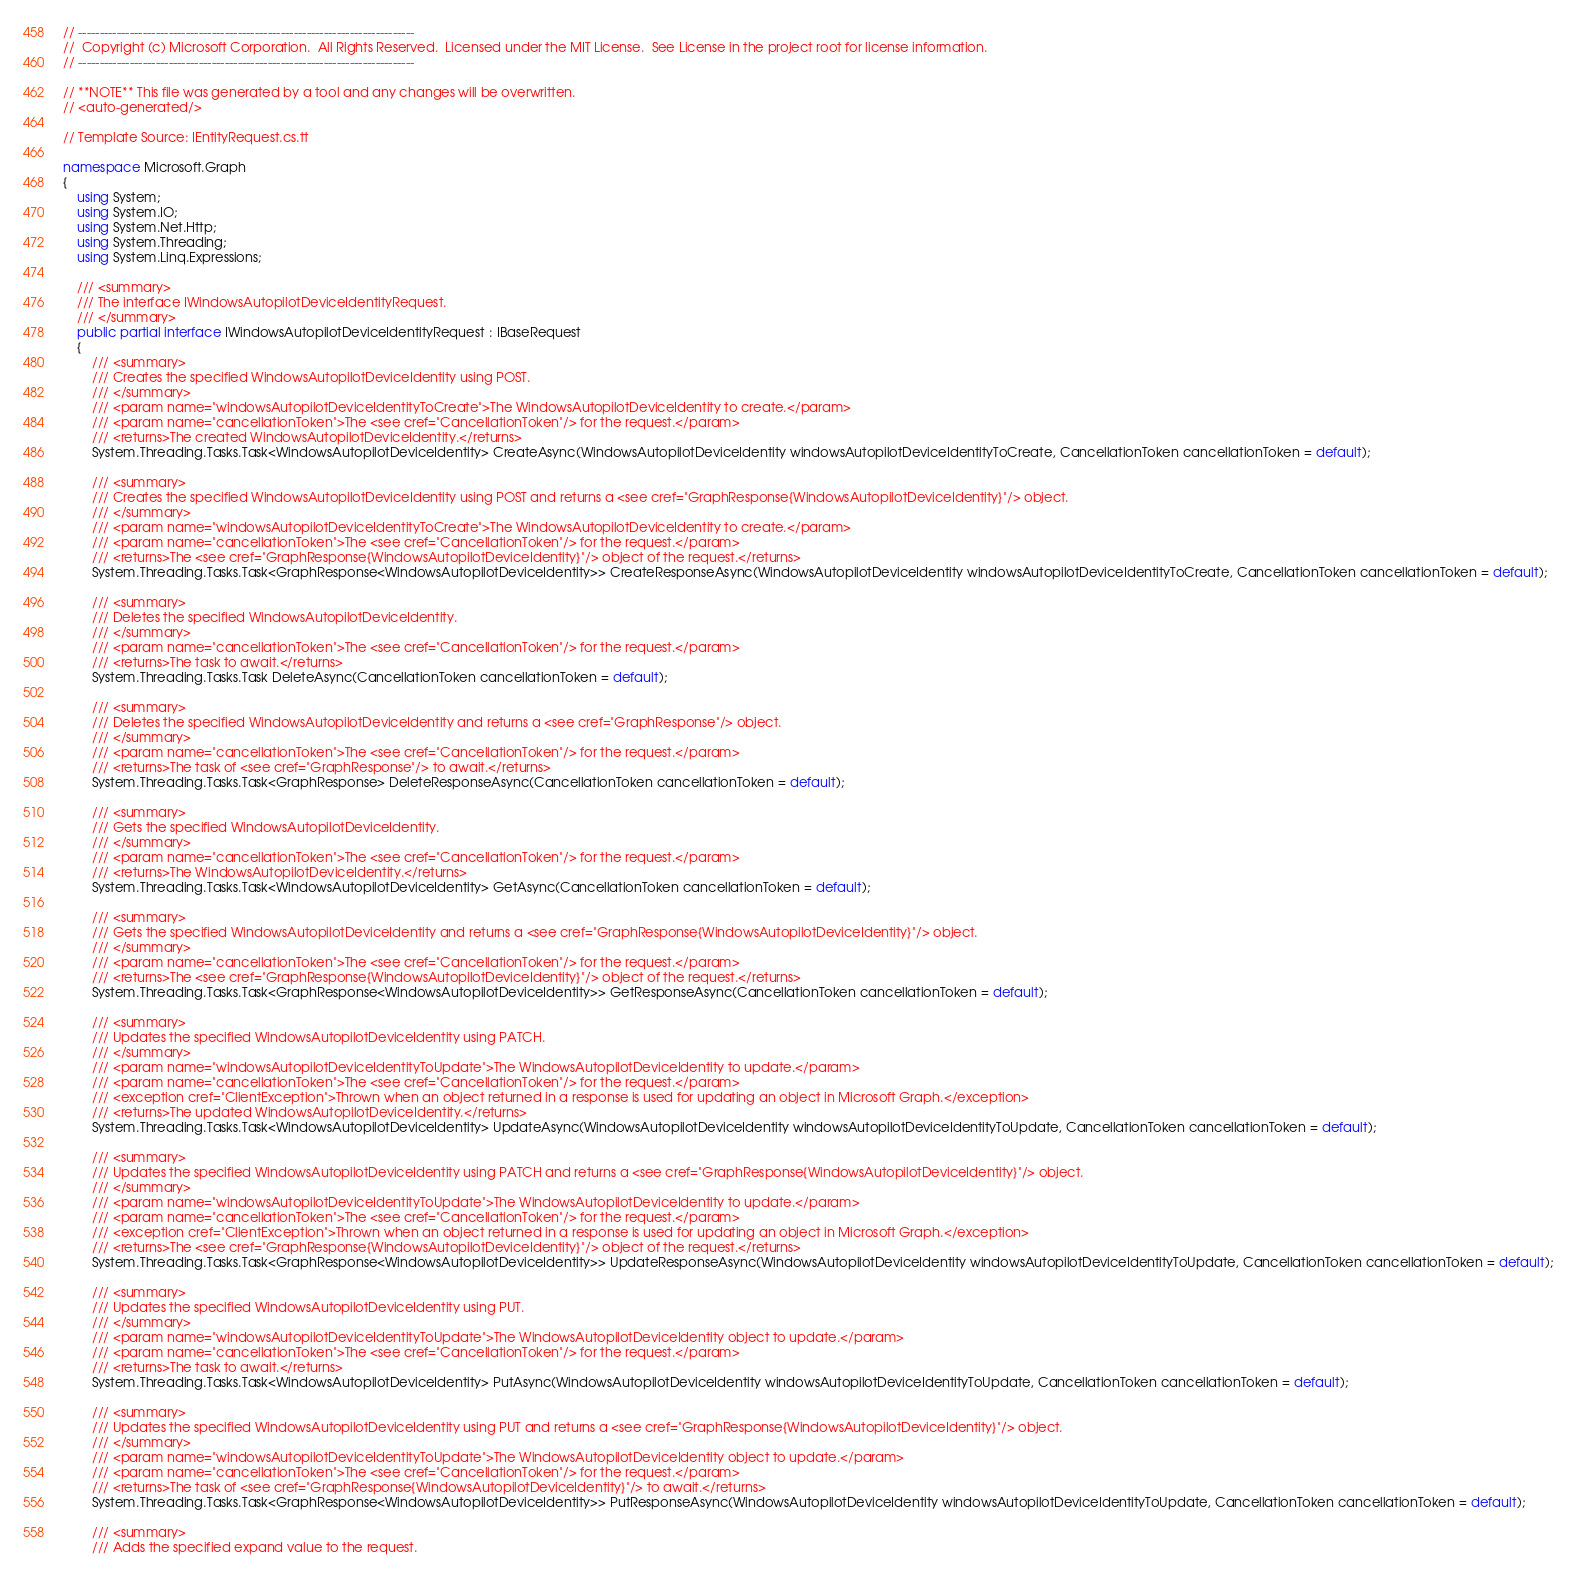<code> <loc_0><loc_0><loc_500><loc_500><_C#_>// ------------------------------------------------------------------------------
//  Copyright (c) Microsoft Corporation.  All Rights Reserved.  Licensed under the MIT License.  See License in the project root for license information.
// ------------------------------------------------------------------------------

// **NOTE** This file was generated by a tool and any changes will be overwritten.
// <auto-generated/>

// Template Source: IEntityRequest.cs.tt

namespace Microsoft.Graph
{
    using System;
    using System.IO;
    using System.Net.Http;
    using System.Threading;
    using System.Linq.Expressions;

    /// <summary>
    /// The interface IWindowsAutopilotDeviceIdentityRequest.
    /// </summary>
    public partial interface IWindowsAutopilotDeviceIdentityRequest : IBaseRequest
    {
        /// <summary>
        /// Creates the specified WindowsAutopilotDeviceIdentity using POST.
        /// </summary>
        /// <param name="windowsAutopilotDeviceIdentityToCreate">The WindowsAutopilotDeviceIdentity to create.</param>
        /// <param name="cancellationToken">The <see cref="CancellationToken"/> for the request.</param>
        /// <returns>The created WindowsAutopilotDeviceIdentity.</returns>
        System.Threading.Tasks.Task<WindowsAutopilotDeviceIdentity> CreateAsync(WindowsAutopilotDeviceIdentity windowsAutopilotDeviceIdentityToCreate, CancellationToken cancellationToken = default);

        /// <summary>
        /// Creates the specified WindowsAutopilotDeviceIdentity using POST and returns a <see cref="GraphResponse{WindowsAutopilotDeviceIdentity}"/> object.
        /// </summary>
        /// <param name="windowsAutopilotDeviceIdentityToCreate">The WindowsAutopilotDeviceIdentity to create.</param>
        /// <param name="cancellationToken">The <see cref="CancellationToken"/> for the request.</param>
        /// <returns>The <see cref="GraphResponse{WindowsAutopilotDeviceIdentity}"/> object of the request.</returns>
        System.Threading.Tasks.Task<GraphResponse<WindowsAutopilotDeviceIdentity>> CreateResponseAsync(WindowsAutopilotDeviceIdentity windowsAutopilotDeviceIdentityToCreate, CancellationToken cancellationToken = default);

        /// <summary>
        /// Deletes the specified WindowsAutopilotDeviceIdentity.
        /// </summary>
        /// <param name="cancellationToken">The <see cref="CancellationToken"/> for the request.</param>
        /// <returns>The task to await.</returns>
        System.Threading.Tasks.Task DeleteAsync(CancellationToken cancellationToken = default);

        /// <summary>
        /// Deletes the specified WindowsAutopilotDeviceIdentity and returns a <see cref="GraphResponse"/> object.
        /// </summary>
        /// <param name="cancellationToken">The <see cref="CancellationToken"/> for the request.</param>
        /// <returns>The task of <see cref="GraphResponse"/> to await.</returns>
        System.Threading.Tasks.Task<GraphResponse> DeleteResponseAsync(CancellationToken cancellationToken = default);

        /// <summary>
        /// Gets the specified WindowsAutopilotDeviceIdentity.
        /// </summary>
        /// <param name="cancellationToken">The <see cref="CancellationToken"/> for the request.</param>
        /// <returns>The WindowsAutopilotDeviceIdentity.</returns>
        System.Threading.Tasks.Task<WindowsAutopilotDeviceIdentity> GetAsync(CancellationToken cancellationToken = default);

        /// <summary>
        /// Gets the specified WindowsAutopilotDeviceIdentity and returns a <see cref="GraphResponse{WindowsAutopilotDeviceIdentity}"/> object.
        /// </summary>
        /// <param name="cancellationToken">The <see cref="CancellationToken"/> for the request.</param>
        /// <returns>The <see cref="GraphResponse{WindowsAutopilotDeviceIdentity}"/> object of the request.</returns>
        System.Threading.Tasks.Task<GraphResponse<WindowsAutopilotDeviceIdentity>> GetResponseAsync(CancellationToken cancellationToken = default);

        /// <summary>
        /// Updates the specified WindowsAutopilotDeviceIdentity using PATCH.
        /// </summary>
        /// <param name="windowsAutopilotDeviceIdentityToUpdate">The WindowsAutopilotDeviceIdentity to update.</param>
        /// <param name="cancellationToken">The <see cref="CancellationToken"/> for the request.</param>
        /// <exception cref="ClientException">Thrown when an object returned in a response is used for updating an object in Microsoft Graph.</exception>
        /// <returns>The updated WindowsAutopilotDeviceIdentity.</returns>
        System.Threading.Tasks.Task<WindowsAutopilotDeviceIdentity> UpdateAsync(WindowsAutopilotDeviceIdentity windowsAutopilotDeviceIdentityToUpdate, CancellationToken cancellationToken = default);

        /// <summary>
        /// Updates the specified WindowsAutopilotDeviceIdentity using PATCH and returns a <see cref="GraphResponse{WindowsAutopilotDeviceIdentity}"/> object.
        /// </summary>
        /// <param name="windowsAutopilotDeviceIdentityToUpdate">The WindowsAutopilotDeviceIdentity to update.</param>
        /// <param name="cancellationToken">The <see cref="CancellationToken"/> for the request.</param>
        /// <exception cref="ClientException">Thrown when an object returned in a response is used for updating an object in Microsoft Graph.</exception>
        /// <returns>The <see cref="GraphResponse{WindowsAutopilotDeviceIdentity}"/> object of the request.</returns>
        System.Threading.Tasks.Task<GraphResponse<WindowsAutopilotDeviceIdentity>> UpdateResponseAsync(WindowsAutopilotDeviceIdentity windowsAutopilotDeviceIdentityToUpdate, CancellationToken cancellationToken = default);

        /// <summary>
        /// Updates the specified WindowsAutopilotDeviceIdentity using PUT.
        /// </summary>
        /// <param name="windowsAutopilotDeviceIdentityToUpdate">The WindowsAutopilotDeviceIdentity object to update.</param>
        /// <param name="cancellationToken">The <see cref="CancellationToken"/> for the request.</param>
        /// <returns>The task to await.</returns>
        System.Threading.Tasks.Task<WindowsAutopilotDeviceIdentity> PutAsync(WindowsAutopilotDeviceIdentity windowsAutopilotDeviceIdentityToUpdate, CancellationToken cancellationToken = default);

        /// <summary>
        /// Updates the specified WindowsAutopilotDeviceIdentity using PUT and returns a <see cref="GraphResponse{WindowsAutopilotDeviceIdentity}"/> object.
        /// </summary>
        /// <param name="windowsAutopilotDeviceIdentityToUpdate">The WindowsAutopilotDeviceIdentity object to update.</param>
        /// <param name="cancellationToken">The <see cref="CancellationToken"/> for the request.</param>
        /// <returns>The task of <see cref="GraphResponse{WindowsAutopilotDeviceIdentity}"/> to await.</returns>
        System.Threading.Tasks.Task<GraphResponse<WindowsAutopilotDeviceIdentity>> PutResponseAsync(WindowsAutopilotDeviceIdentity windowsAutopilotDeviceIdentityToUpdate, CancellationToken cancellationToken = default);

        /// <summary>
        /// Adds the specified expand value to the request.</code> 